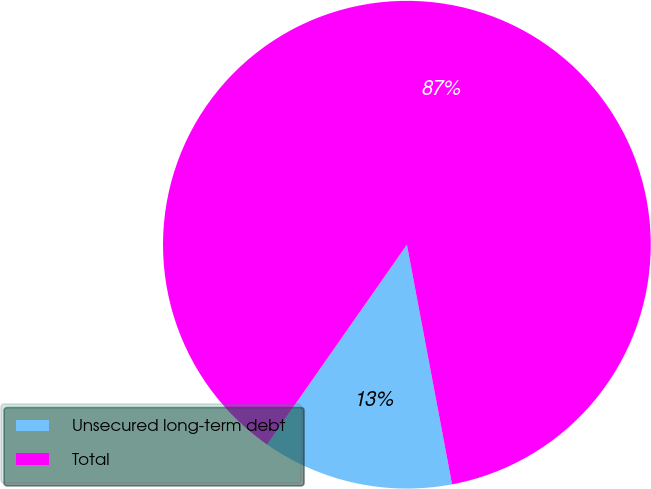Convert chart. <chart><loc_0><loc_0><loc_500><loc_500><pie_chart><fcel>Unsecured long-term debt<fcel>Total<nl><fcel>12.68%<fcel>87.32%<nl></chart> 